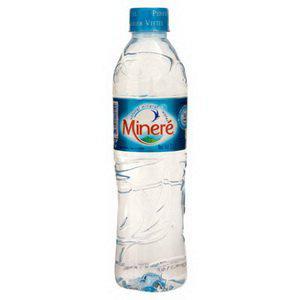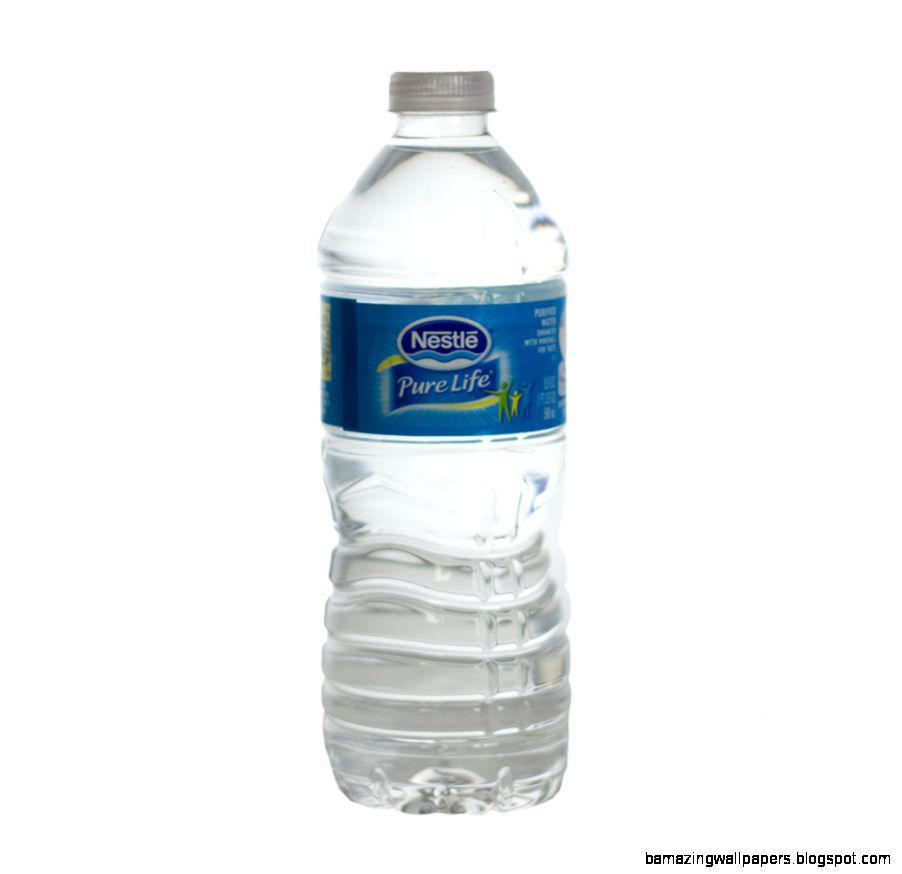The first image is the image on the left, the second image is the image on the right. For the images displayed, is the sentence "There are exactly two bottles." factually correct? Answer yes or no. Yes. 